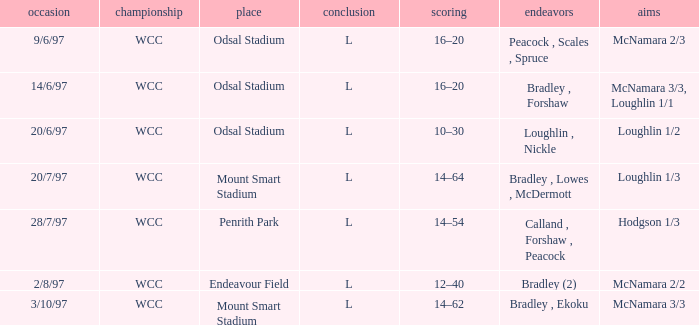What were the endeavors on 14/6/97? Bradley , Forshaw. 